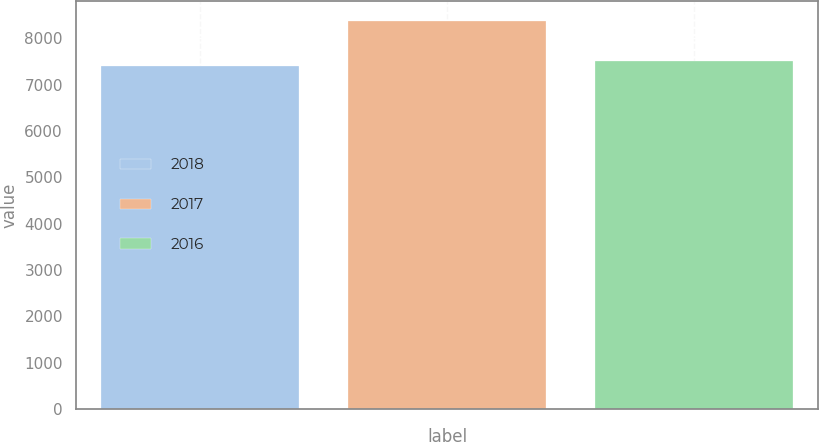<chart> <loc_0><loc_0><loc_500><loc_500><bar_chart><fcel>2018<fcel>2017<fcel>2016<nl><fcel>7406<fcel>8380<fcel>7516<nl></chart> 